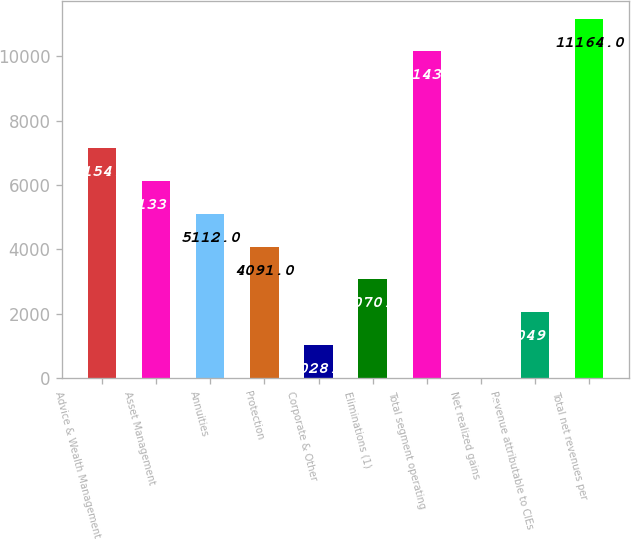<chart> <loc_0><loc_0><loc_500><loc_500><bar_chart><fcel>Advice & Wealth Management<fcel>Asset Management<fcel>Annuities<fcel>Protection<fcel>Corporate & Other<fcel>Eliminations (1)<fcel>Total segment operating<fcel>Net realized gains<fcel>Revenue attributable to CIEs<fcel>Total net revenues per<nl><fcel>7154<fcel>6133<fcel>5112<fcel>4091<fcel>1028<fcel>3070<fcel>10143<fcel>7<fcel>2049<fcel>11164<nl></chart> 